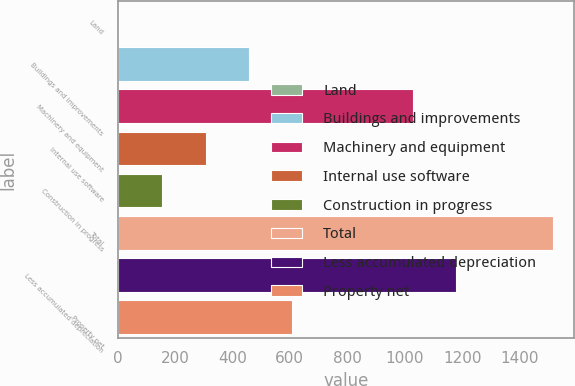Convert chart to OTSL. <chart><loc_0><loc_0><loc_500><loc_500><bar_chart><fcel>Land<fcel>Buildings and improvements<fcel>Machinery and equipment<fcel>Internal use software<fcel>Construction in progress<fcel>Total<fcel>Less accumulated depreciation<fcel>Property net<nl><fcel>5.1<fcel>458.28<fcel>1028.4<fcel>307.22<fcel>156.16<fcel>1515.7<fcel>1179.46<fcel>609.34<nl></chart> 